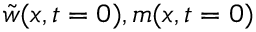Convert formula to latex. <formula><loc_0><loc_0><loc_500><loc_500>\tilde { w } ( x , t = 0 ) , m ( x , t = 0 )</formula> 